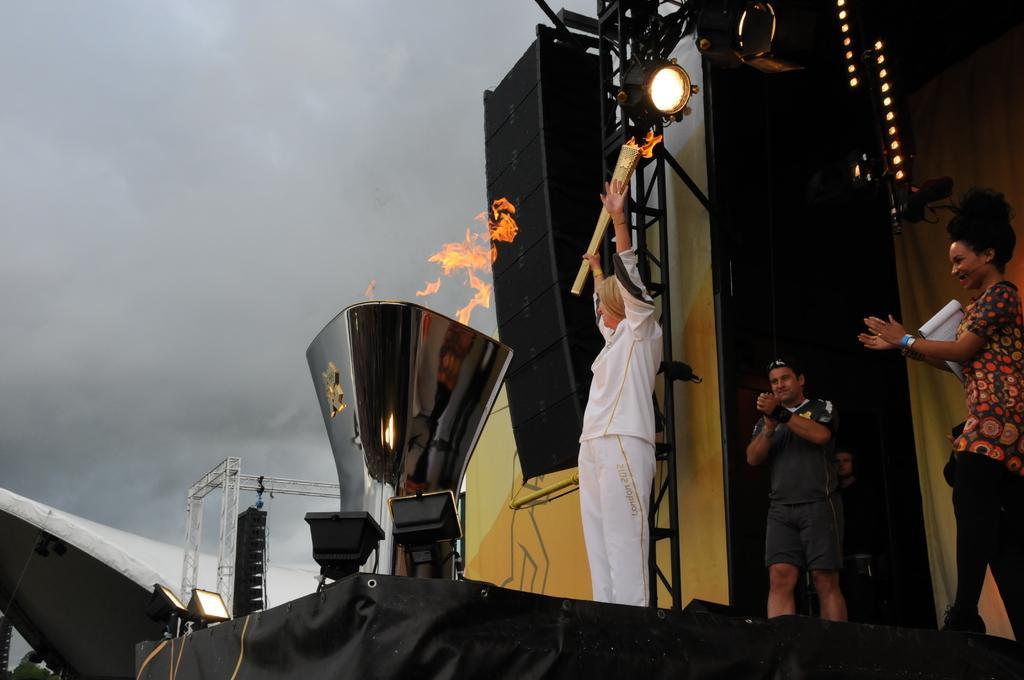How would you summarize this image in a sentence or two? In this image we can see few people on the stage and holding some objects. There are many objects in the image. There are few light sin the image. We can see the cloudy sky in the image. There is a fire in the image. 